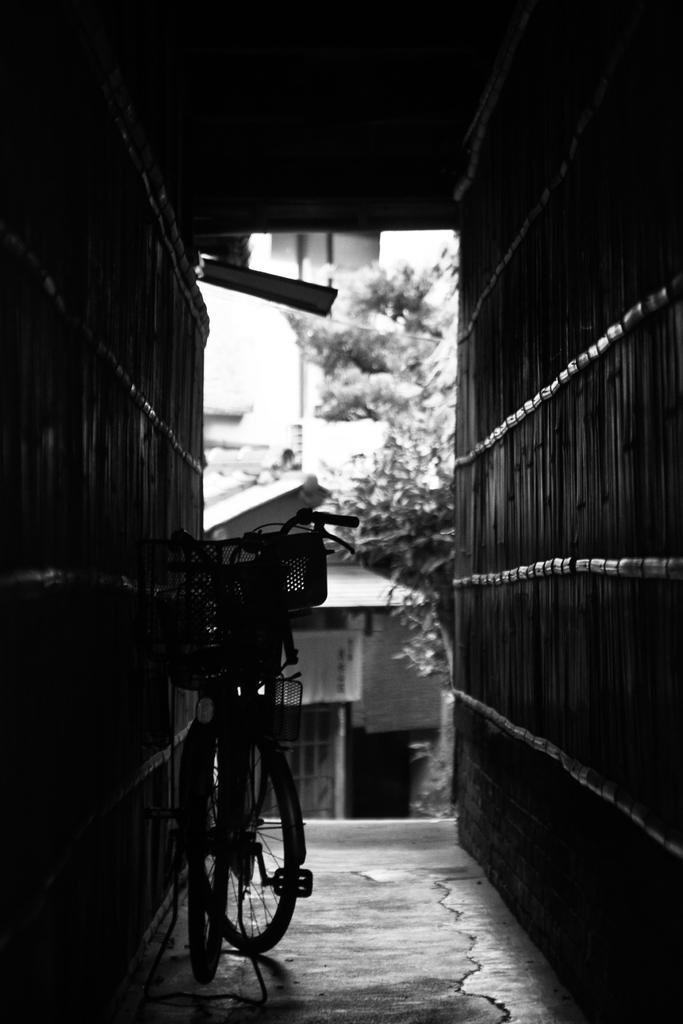Can you describe this image briefly? In this picture I can see a bicycle and I can see few houses and trees. 